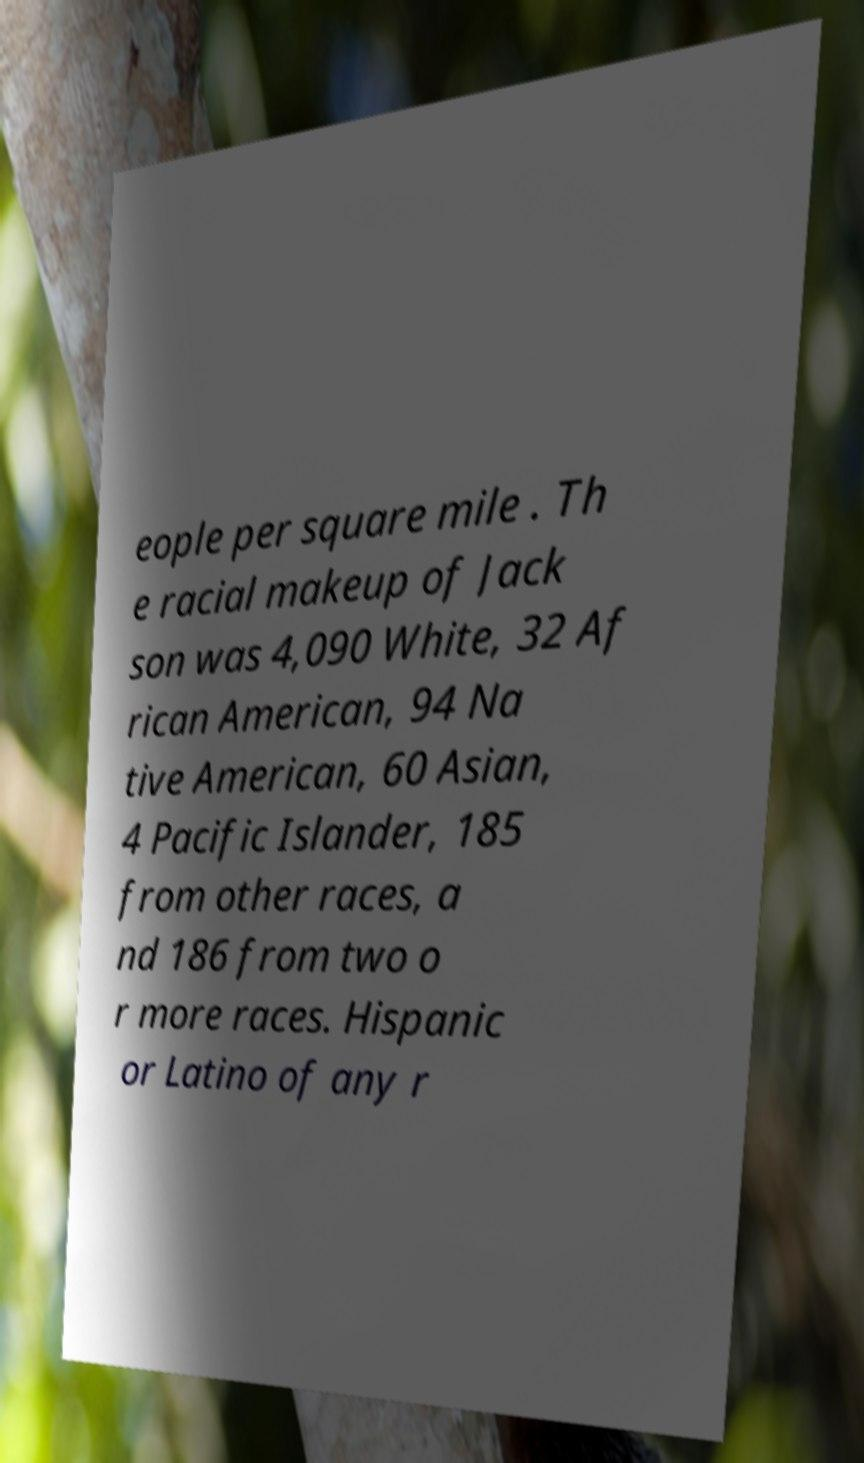Could you assist in decoding the text presented in this image and type it out clearly? eople per square mile . Th e racial makeup of Jack son was 4,090 White, 32 Af rican American, 94 Na tive American, 60 Asian, 4 Pacific Islander, 185 from other races, a nd 186 from two o r more races. Hispanic or Latino of any r 